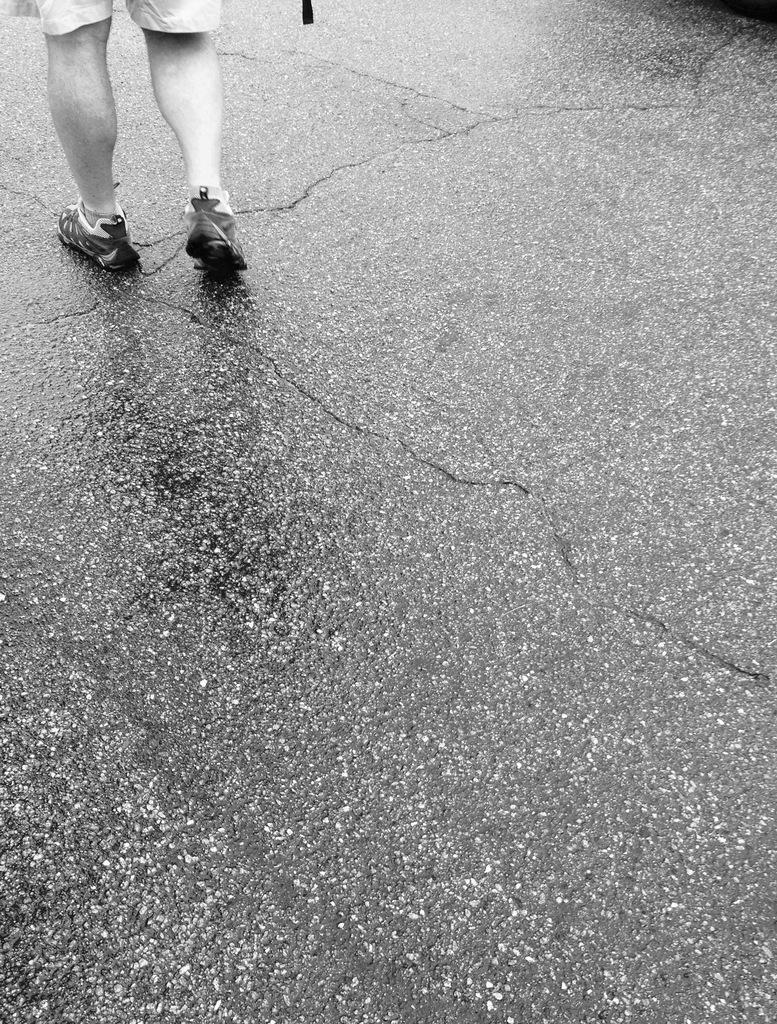How would you summarize this image in a sentence or two? In this image we can see a person standing on the road. This is a black and white picture. 